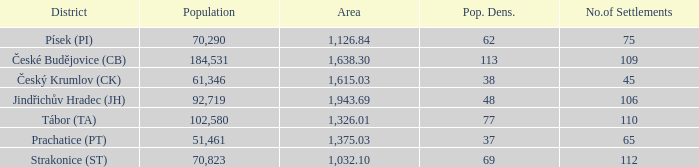How big is the area that has a population density of 113 and a population larger than 184,531? 0.0. 